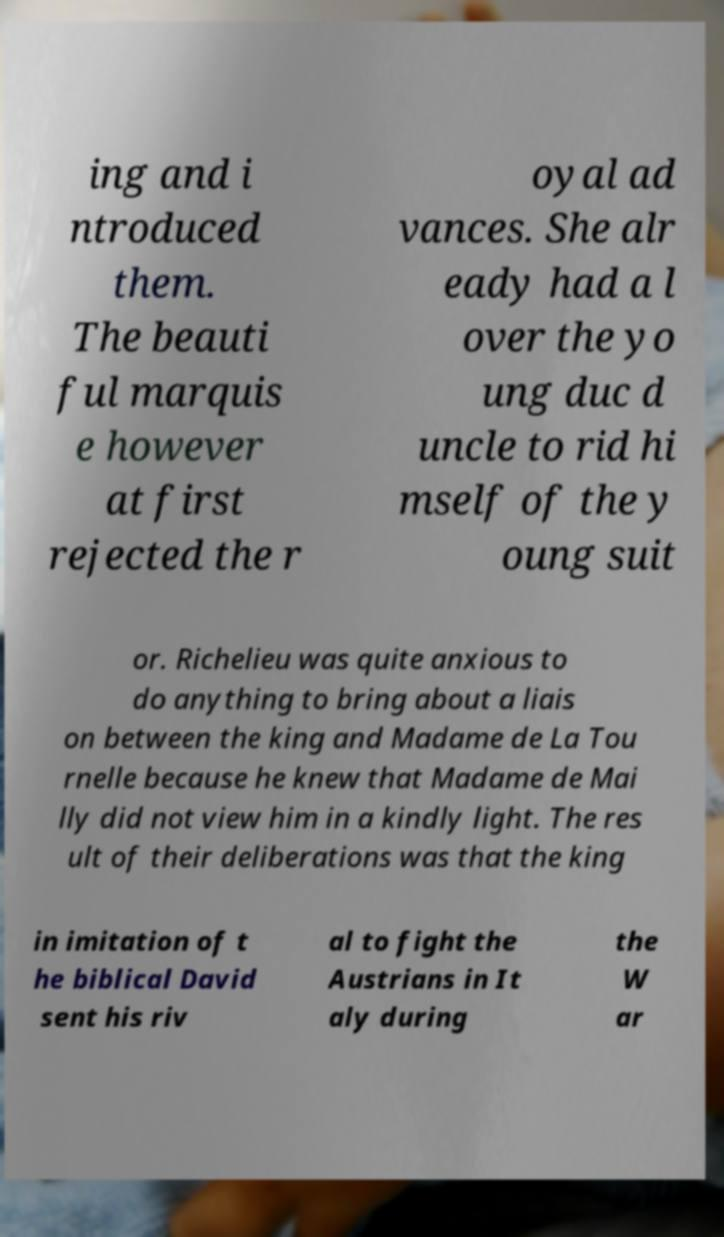There's text embedded in this image that I need extracted. Can you transcribe it verbatim? ing and i ntroduced them. The beauti ful marquis e however at first rejected the r oyal ad vances. She alr eady had a l over the yo ung duc d uncle to rid hi mself of the y oung suit or. Richelieu was quite anxious to do anything to bring about a liais on between the king and Madame de La Tou rnelle because he knew that Madame de Mai lly did not view him in a kindly light. The res ult of their deliberations was that the king in imitation of t he biblical David sent his riv al to fight the Austrians in It aly during the W ar 